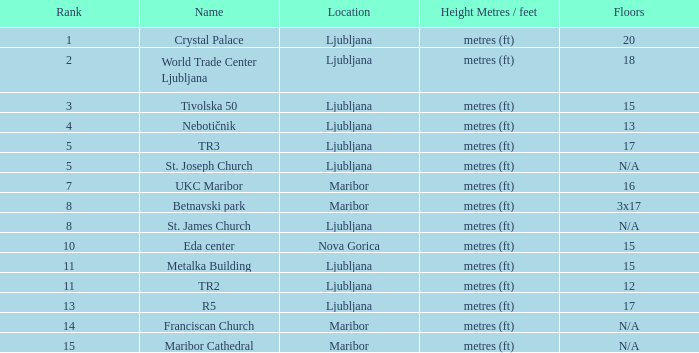Which Height Metres / feet has a Rank of 8, and Floors of 3x17? Metres (ft). 